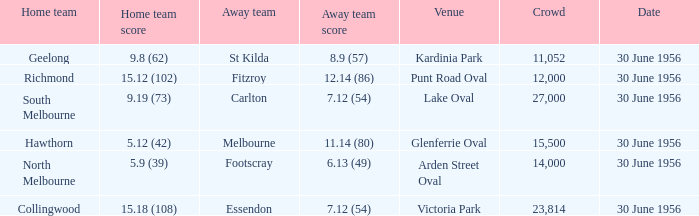What is the home team at Victoria Park with an Away team score of 7.12 (54) and more than 12,000 people? Collingwood. 